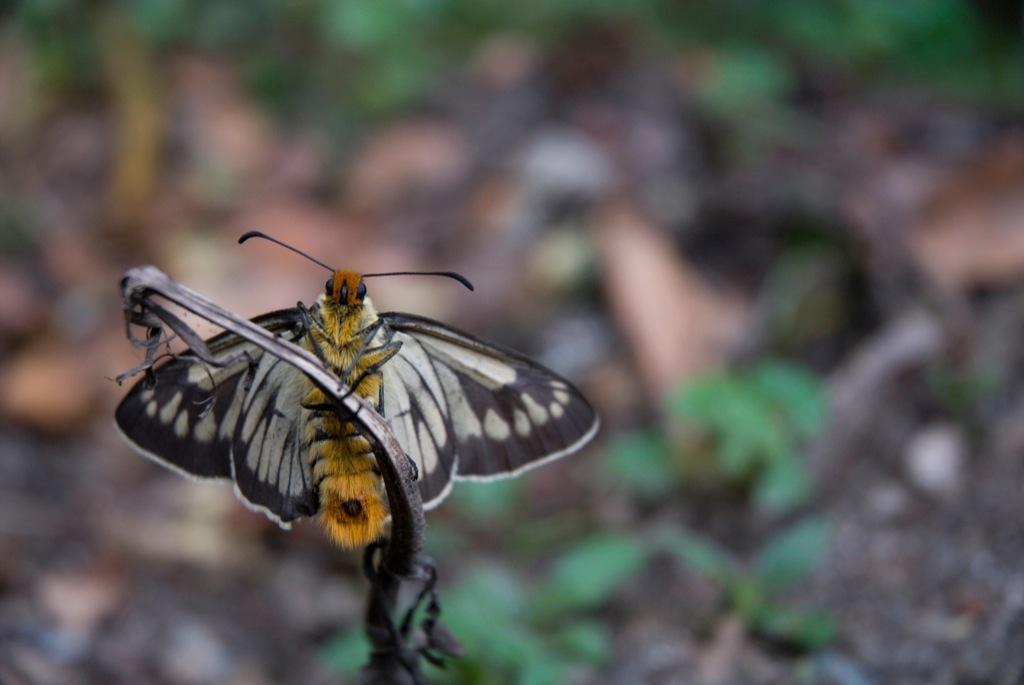What is the main subject of the image? There is a plant in the image. What can be seen on the plant? A butterfly is present on the plant. What else is visible in the background of the image? There are plants and land visible in the background of the image. What type of circle can be seen on the wrist of the butterfly in the image? There is no wrist or circle present on the butterfly in the image. What direction is the train moving in the image? There is no train present in the image. 